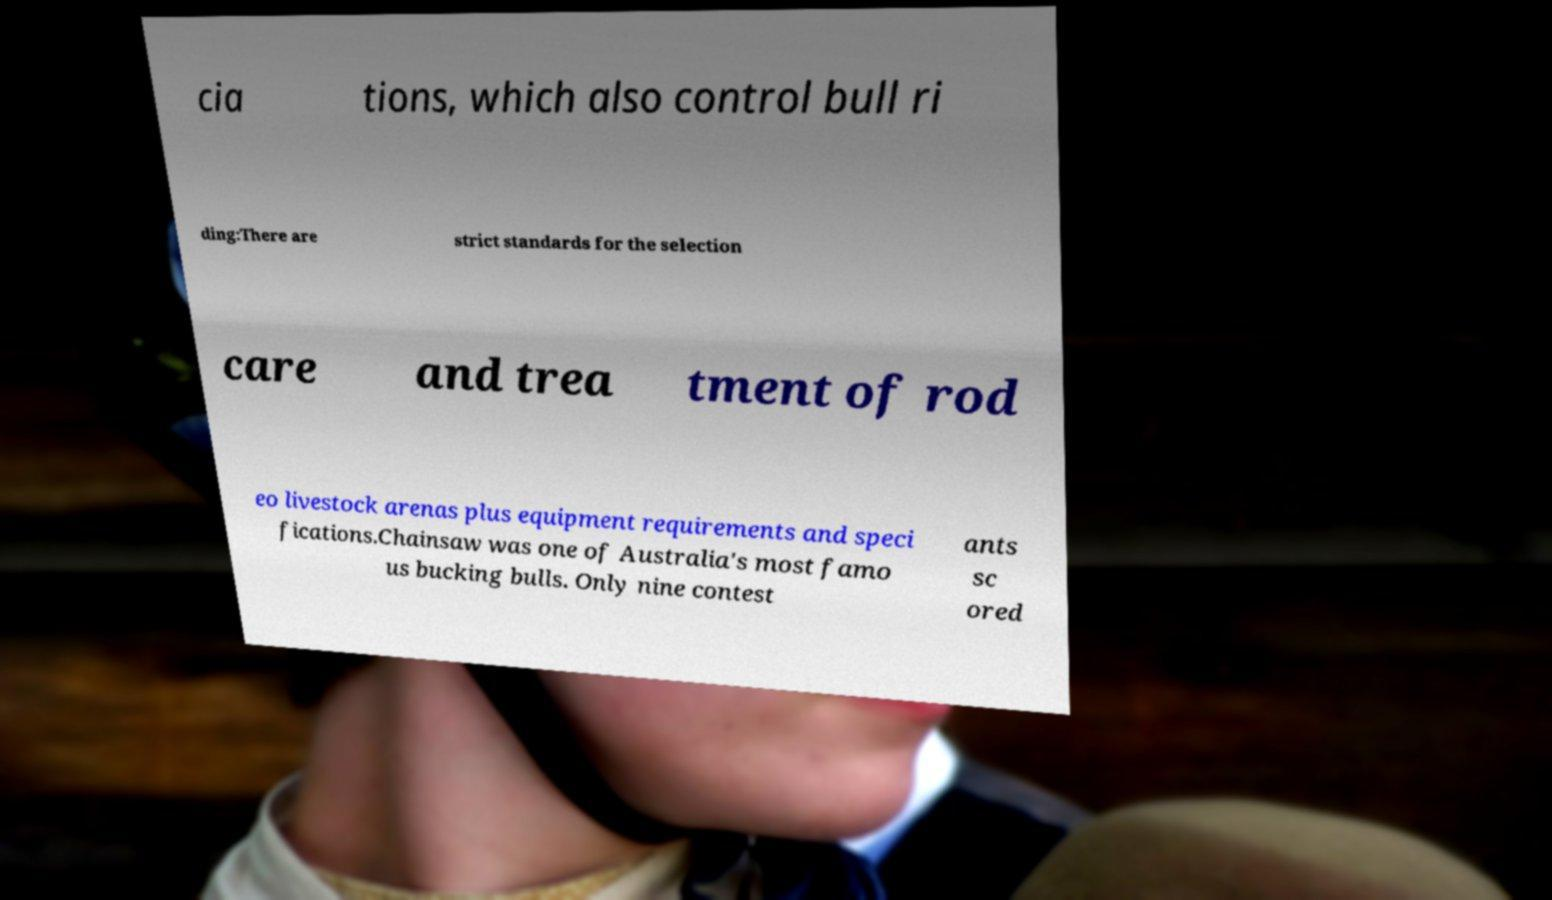Can you accurately transcribe the text from the provided image for me? cia tions, which also control bull ri ding:There are strict standards for the selection care and trea tment of rod eo livestock arenas plus equipment requirements and speci fications.Chainsaw was one of Australia's most famo us bucking bulls. Only nine contest ants sc ored 